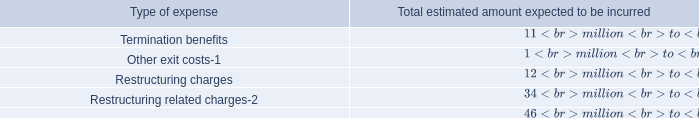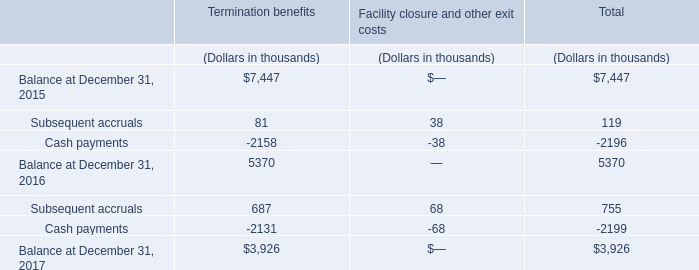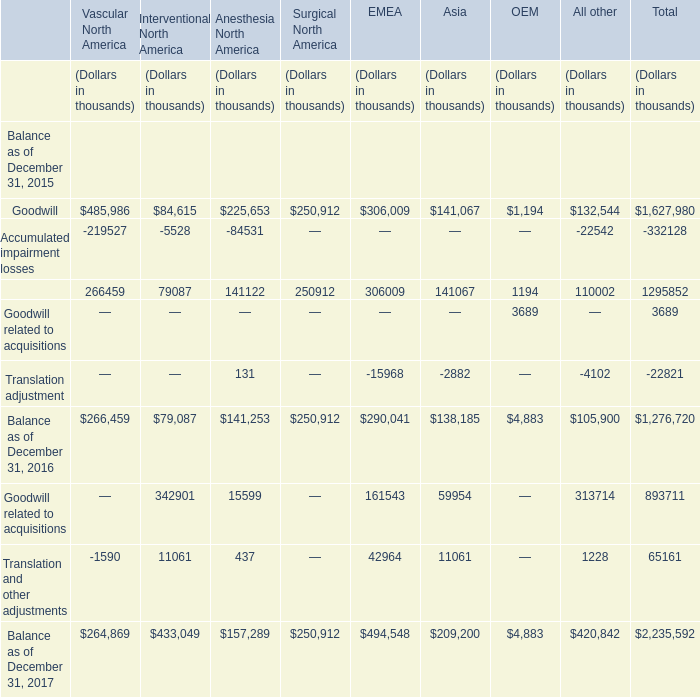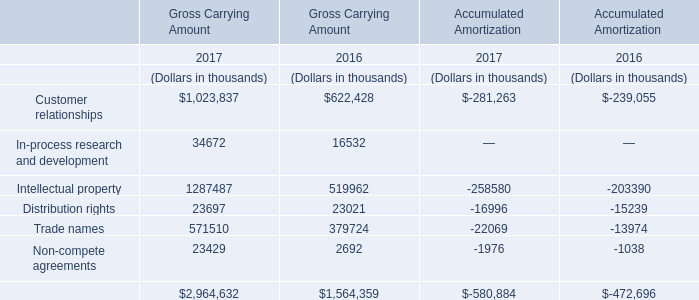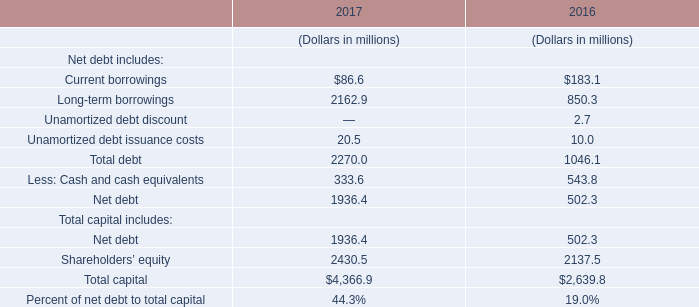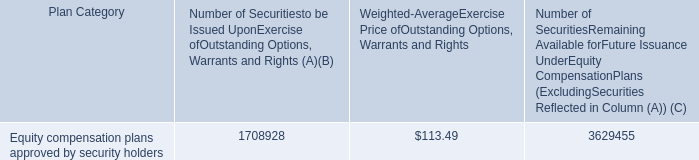if the remaining securities would be use or exercised at $ 113.49 , what would cost be for the company? 
Computations: (113.49 * 3629455)
Answer: 411906847.95. 